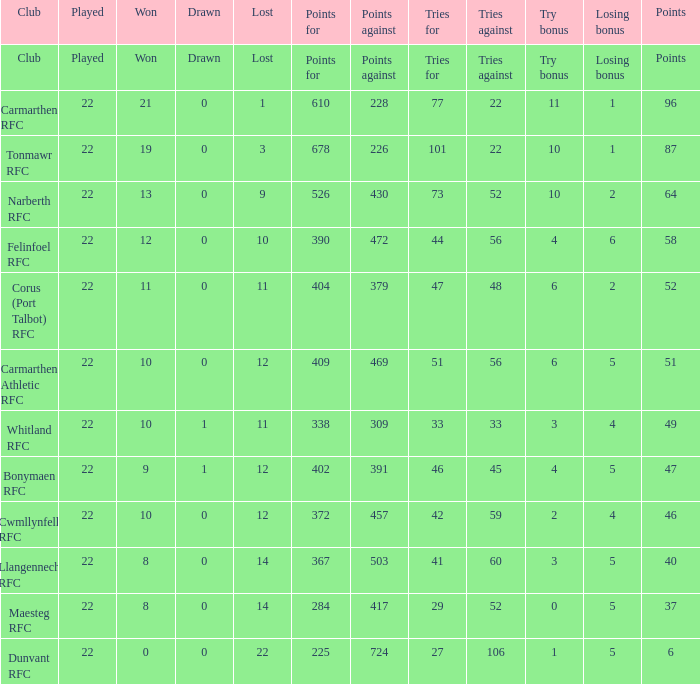Name the losing bonus of 96 points 1.0. 